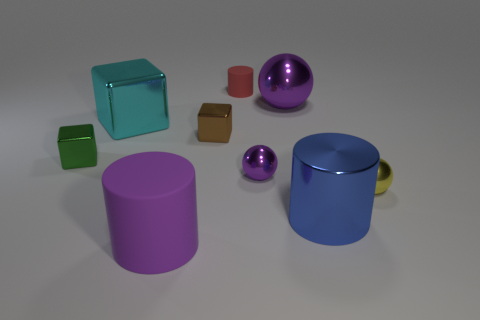Is there a big shiny thing that has the same color as the large sphere?
Keep it short and to the point. No. What number of tiny purple shiny spheres are there?
Your answer should be compact. 1. There is a big cylinder that is to the left of the matte thing that is to the right of the big purple object that is in front of the large purple ball; what is it made of?
Your answer should be compact. Rubber. Are there any red cubes made of the same material as the small brown object?
Ensure brevity in your answer.  No. Do the brown object and the tiny green cube have the same material?
Give a very brief answer. Yes. How many blocks are purple shiny things or small brown objects?
Your response must be concise. 1. What is the color of the cylinder that is the same material as the cyan thing?
Make the answer very short. Blue. Is the number of green things less than the number of large red things?
Offer a very short reply. No. Is the shape of the metal thing right of the blue metal cylinder the same as the matte thing behind the yellow metal object?
Make the answer very short. No. How many things are either small blue cubes or purple matte cylinders?
Provide a short and direct response. 1. 